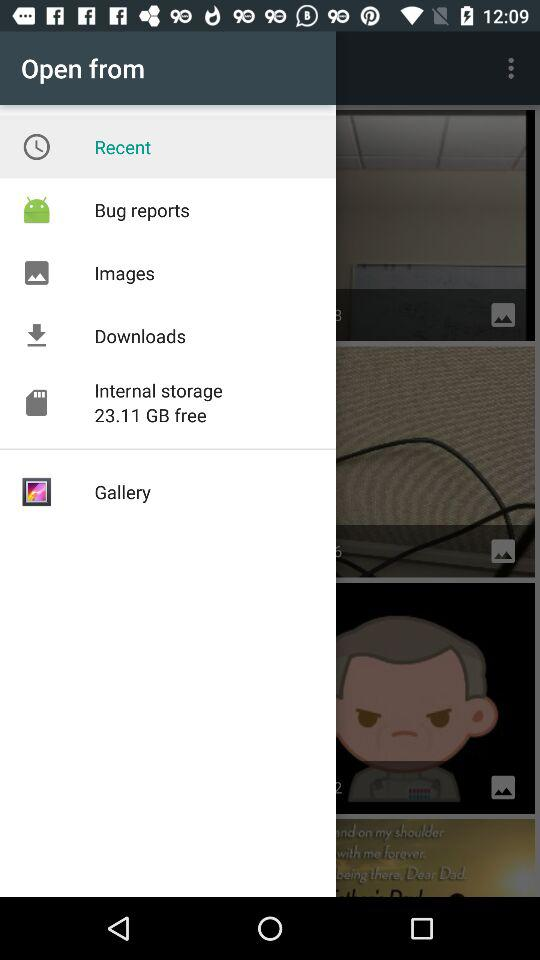What is the name of the item that has the most free storage space?
Answer the question using a single word or phrase. Internal storage 